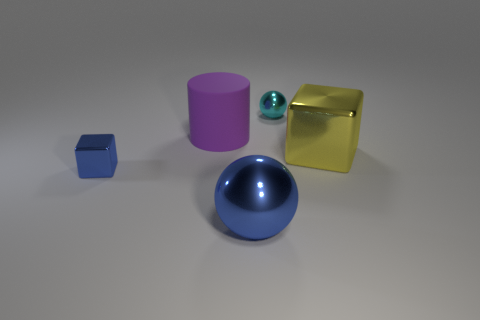What number of large things are blocks or cylinders?
Your response must be concise. 2. What number of other objects are made of the same material as the yellow object?
Your response must be concise. 3. There is a cube to the left of the small ball; what size is it?
Your answer should be compact. Small. There is a tiny thing on the left side of the small metal object that is on the right side of the tiny blue block; what shape is it?
Your response must be concise. Cube. How many small metallic objects are in front of the small metallic thing that is on the right side of the blue thing on the right side of the big purple cylinder?
Keep it short and to the point. 1. Are there fewer small cyan objects that are to the left of the tiny metal ball than shiny cylinders?
Provide a succinct answer. No. Is there any other thing that is the same shape as the big matte thing?
Your response must be concise. No. What is the shape of the small thing on the left side of the purple matte cylinder?
Provide a short and direct response. Cube. The small shiny object right of the sphere that is left of the shiny ball that is behind the cylinder is what shape?
Offer a very short reply. Sphere. What number of objects are big green cubes or blue metal spheres?
Give a very brief answer. 1. 